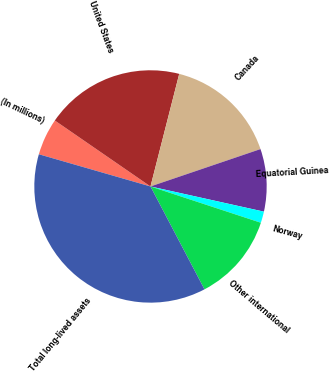<chart> <loc_0><loc_0><loc_500><loc_500><pie_chart><fcel>(In millions)<fcel>United States<fcel>Canada<fcel>Equatorial Guinea<fcel>Norway<fcel>Other international<fcel>Total long-lived assets<nl><fcel>5.14%<fcel>19.37%<fcel>15.81%<fcel>8.69%<fcel>1.58%<fcel>12.25%<fcel>37.16%<nl></chart> 